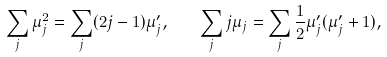<formula> <loc_0><loc_0><loc_500><loc_500>\sum _ { j } \mu _ { j } ^ { 2 } = \sum _ { j } ( 2 j - 1 ) \mu _ { j } ^ { \prime } , \quad \sum _ { j } j \mu _ { j } = \sum _ { j } \frac { 1 } { 2 } \mu _ { j } ^ { \prime } ( \mu _ { j } ^ { \prime } + 1 ) ,</formula> 